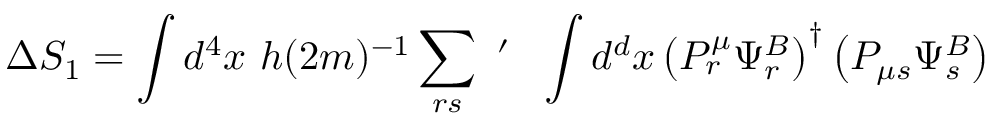Convert formula to latex. <formula><loc_0><loc_0><loc_500><loc_500>\Delta S _ { 1 } = \int d ^ { 4 } x h ( 2 m ) ^ { - 1 } \sum _ { r s } ^ { \prime } \int d ^ { d } x \left ( P _ { r } ^ { \mu } \Psi _ { r } ^ { B } \right ) ^ { \dagger } \left ( P _ { \mu s } \Psi _ { s } ^ { B } \right )</formula> 